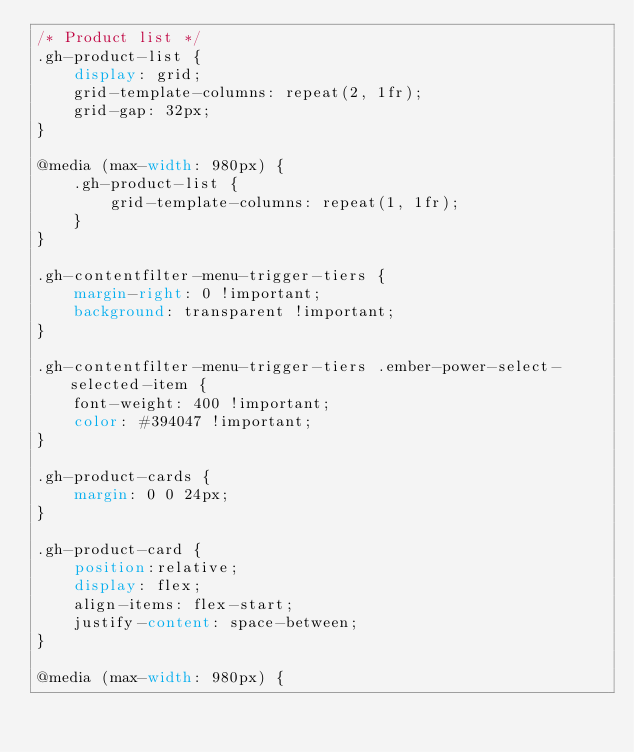Convert code to text. <code><loc_0><loc_0><loc_500><loc_500><_CSS_>/* Product list */
.gh-product-list {
    display: grid;
    grid-template-columns: repeat(2, 1fr);
    grid-gap: 32px;
}

@media (max-width: 980px) {
    .gh-product-list {
        grid-template-columns: repeat(1, 1fr);
    }
}

.gh-contentfilter-menu-trigger-tiers {
    margin-right: 0 !important;
    background: transparent !important;
}

.gh-contentfilter-menu-trigger-tiers .ember-power-select-selected-item {
    font-weight: 400 !important;
    color: #394047 !important;
}

.gh-product-cards {
    margin: 0 0 24px;
}

.gh-product-card {
    position:relative;
    display: flex;
    align-items: flex-start;
    justify-content: space-between;
}

@media (max-width: 980px) {</code> 